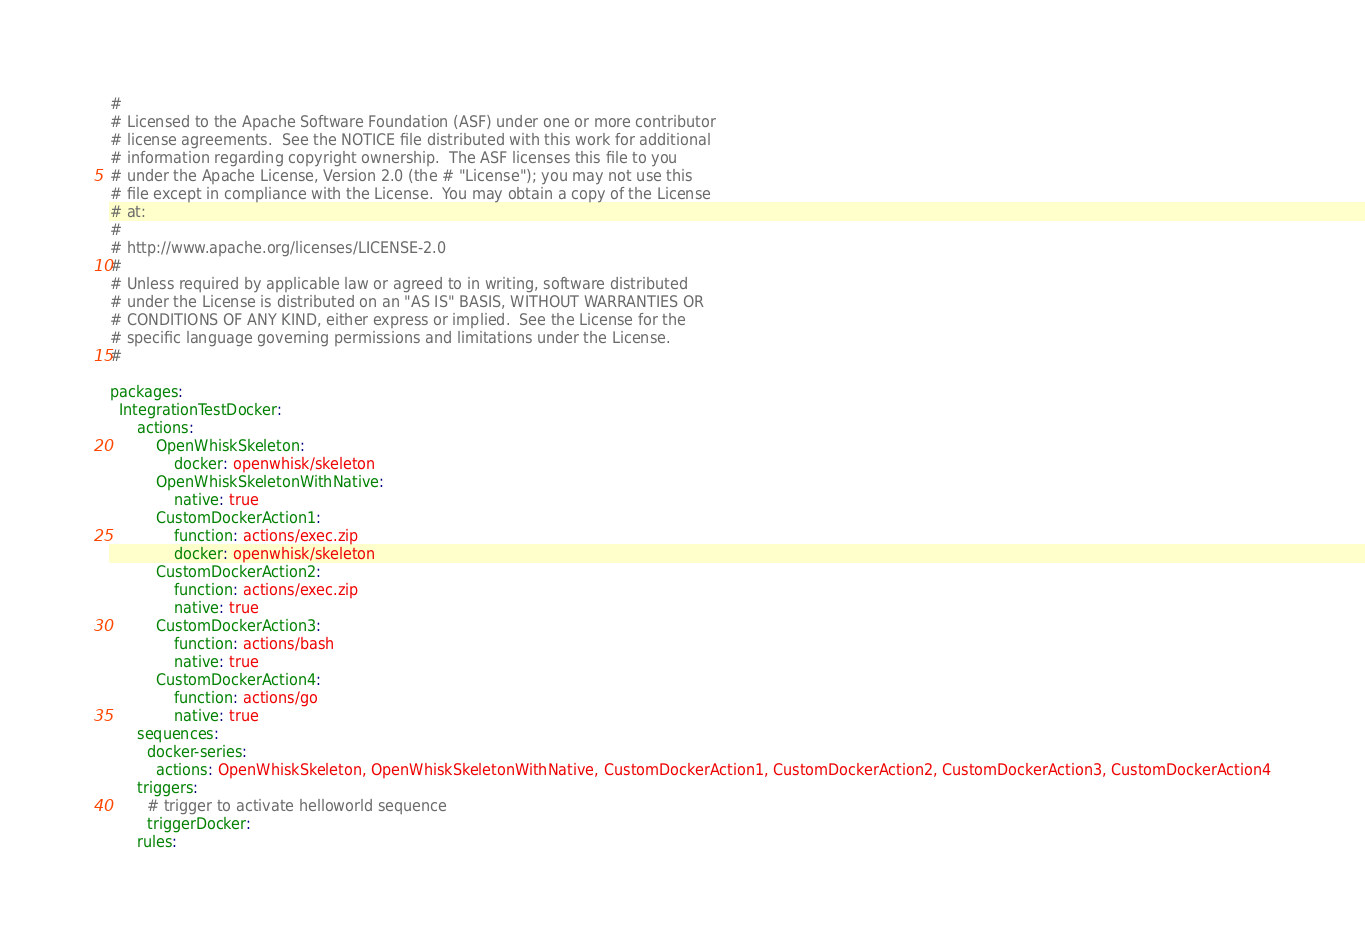<code> <loc_0><loc_0><loc_500><loc_500><_YAML_>#
# Licensed to the Apache Software Foundation (ASF) under one or more contributor
# license agreements.  See the NOTICE file distributed with this work for additional
# information regarding copyright ownership.  The ASF licenses this file to you
# under the Apache License, Version 2.0 (the # "License"); you may not use this
# file except in compliance with the License.  You may obtain a copy of the License
# at:
#
# http://www.apache.org/licenses/LICENSE-2.0
#
# Unless required by applicable law or agreed to in writing, software distributed
# under the License is distributed on an "AS IS" BASIS, WITHOUT WARRANTIES OR
# CONDITIONS OF ANY KIND, either express or implied.  See the License for the
# specific language governing permissions and limitations under the License.
#

packages:
  IntegrationTestDocker:
      actions:
          OpenWhiskSkeleton:
              docker: openwhisk/skeleton
          OpenWhiskSkeletonWithNative:
              native: true
          CustomDockerAction1:
              function: actions/exec.zip
              docker: openwhisk/skeleton
          CustomDockerAction2:
              function: actions/exec.zip
              native: true
          CustomDockerAction3:
              function: actions/bash
              native: true
          CustomDockerAction4:
              function: actions/go
              native: true
      sequences:
        docker-series:
          actions: OpenWhiskSkeleton, OpenWhiskSkeletonWithNative, CustomDockerAction1, CustomDockerAction2, CustomDockerAction3, CustomDockerAction4
      triggers:
        # trigger to activate helloworld sequence
        triggerDocker:
      rules:</code> 